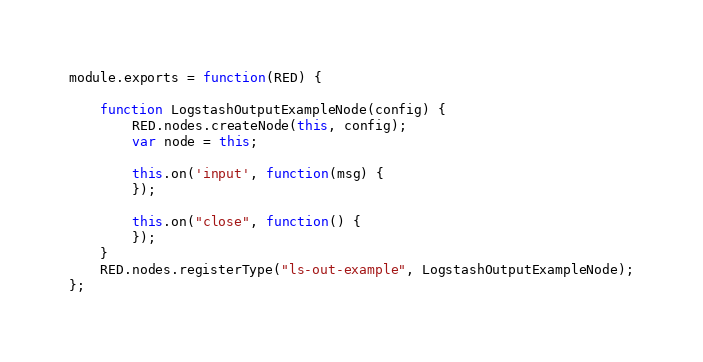Convert code to text. <code><loc_0><loc_0><loc_500><loc_500><_JavaScript_>module.exports = function(RED) {

    function LogstashOutputExampleNode(config) {
        RED.nodes.createNode(this, config);
        var node = this;

        this.on('input', function(msg) {
        });

        this.on("close", function() {
        });
    }
    RED.nodes.registerType("ls-out-example", LogstashOutputExampleNode);
};
</code> 